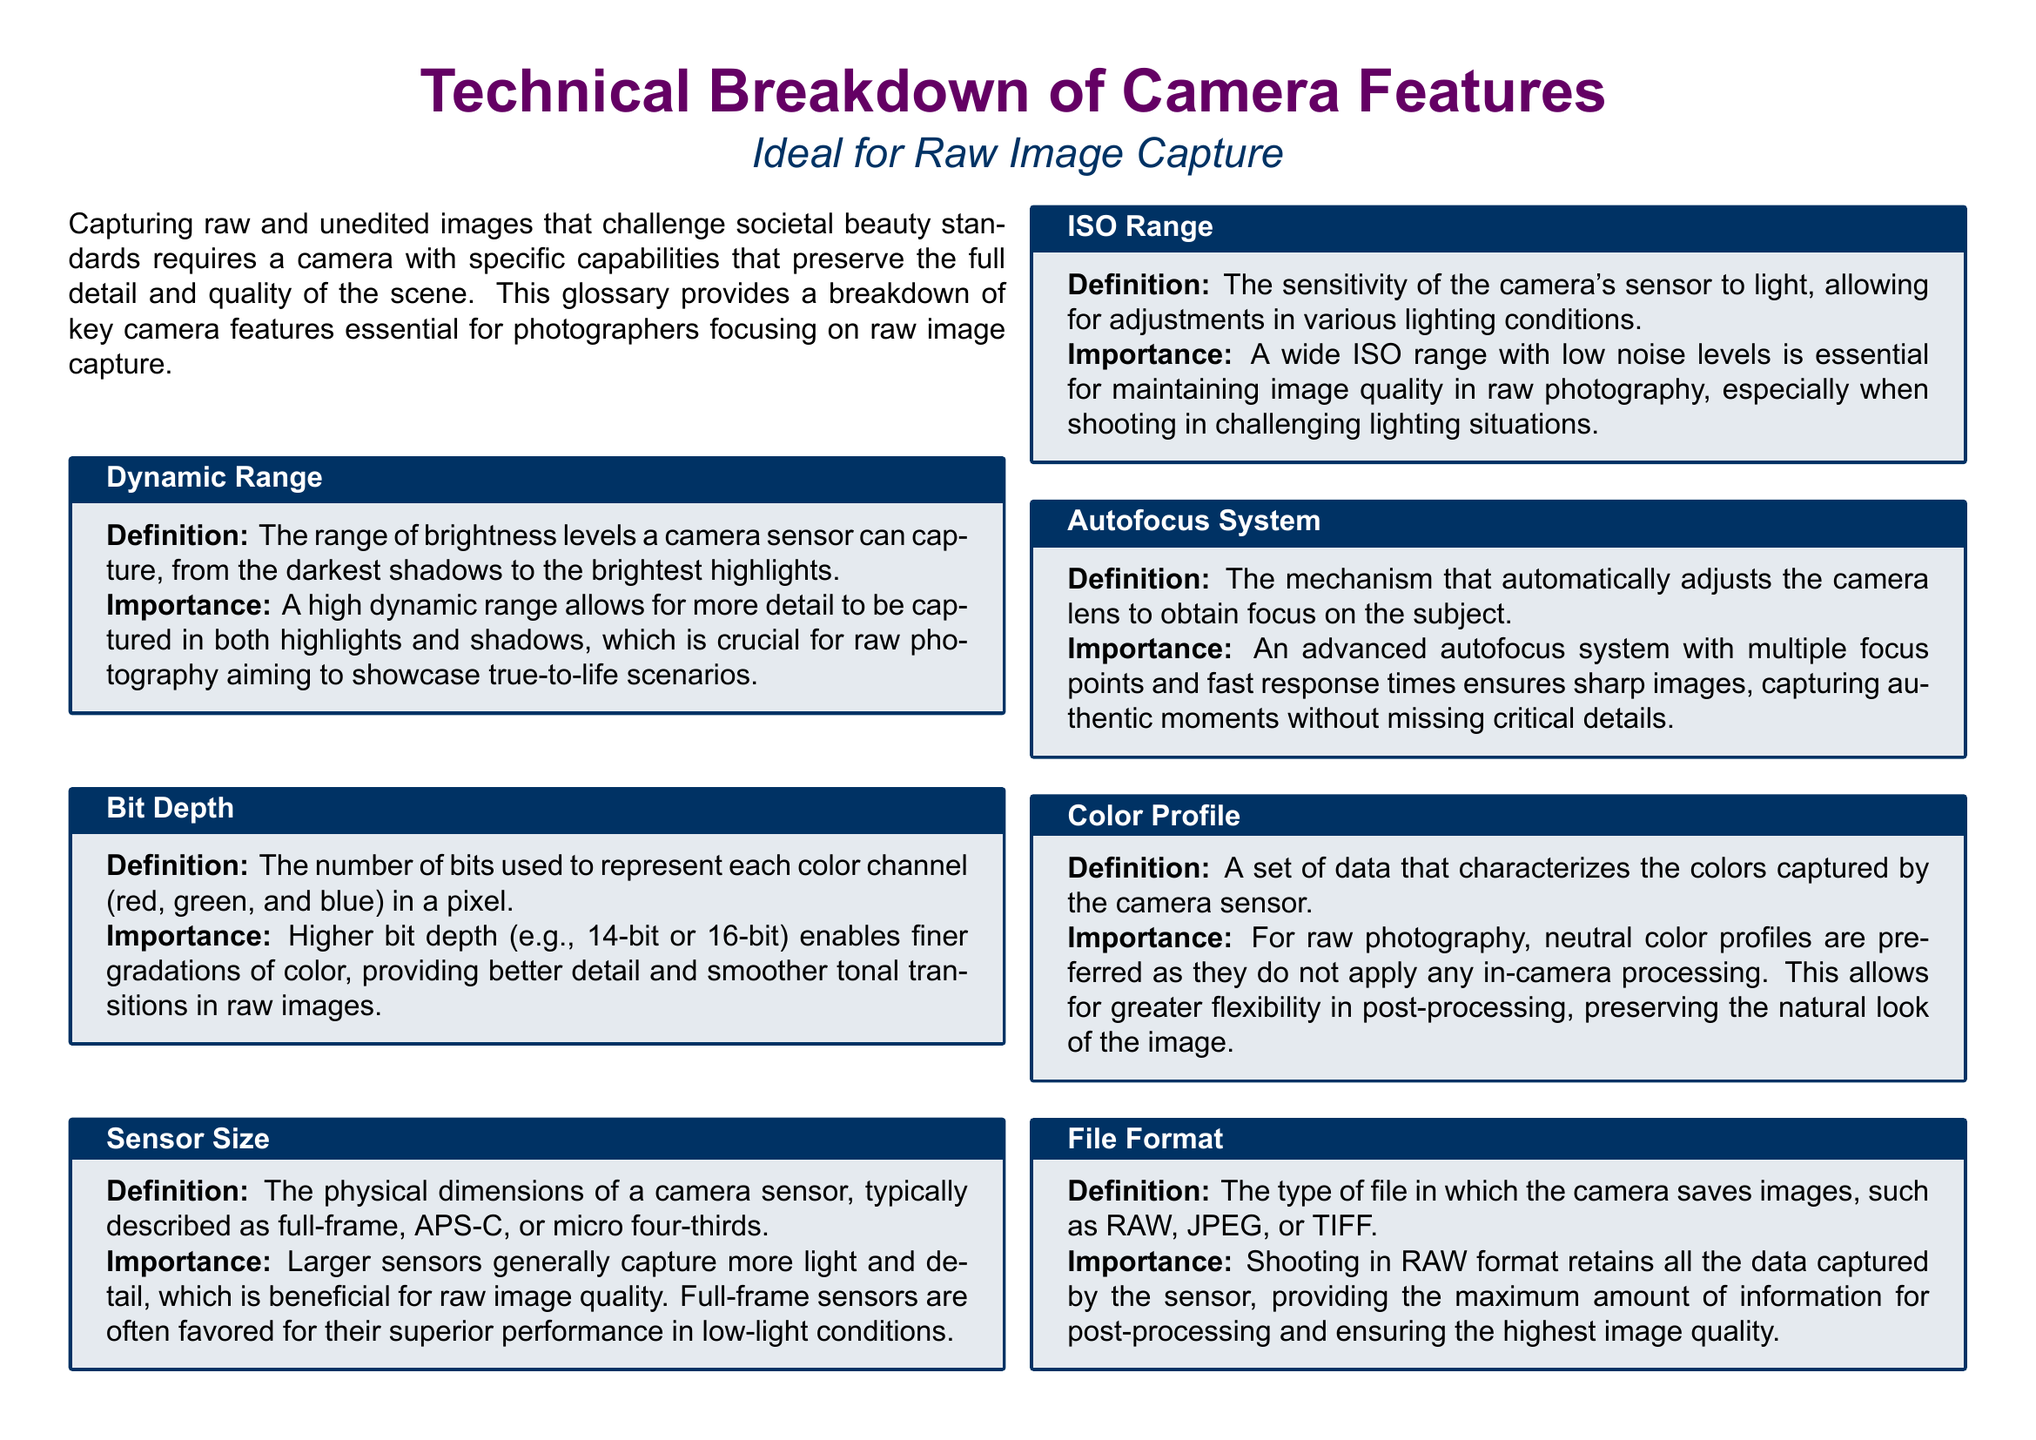What is dynamic range? Dynamic range is defined in the document as the range of brightness levels a camera sensor can capture, from darkest shadows to brightest highlights.
Answer: Range of brightness levels What does a higher bit depth provide? The document specifies that higher bit depth enables finer gradations of color, providing better detail and smoother tonal transitions in raw images.
Answer: Finer gradations of color What is the importance of sensor size? According to the document, larger sensors generally capture more light and detail, which is beneficial for raw image quality.
Answer: Capture more light and detail What is the preferred file format for capturing raw images? The document mentions that shooting in RAW format retains all the data captured by the sensor, providing maximum information for post-processing.
Answer: RAW format What is the main benefit of an advanced autofocus system? The document states that an advanced autofocus system ensures sharp images, capturing authentic moments without missing critical details.
Answer: Ensures sharp images Why are neutral color profiles preferred for raw photography? The document explains that neutral color profiles do not apply any in-camera processing, allowing for greater flexibility in post-processing.
Answer: Greater flexibility in post-processing How does effective image stabilization help photographers? According to the document, effective image stabilization allows for sharper images in lower light or handheld conditions, facilitating spontaneous and authentic moments.
Answer: Sharper images in lower light What do white balance controls adjust? The document describes white balance controls as adjusting the color balance to make image colors appear natural.
Answer: Color balance adjustments 